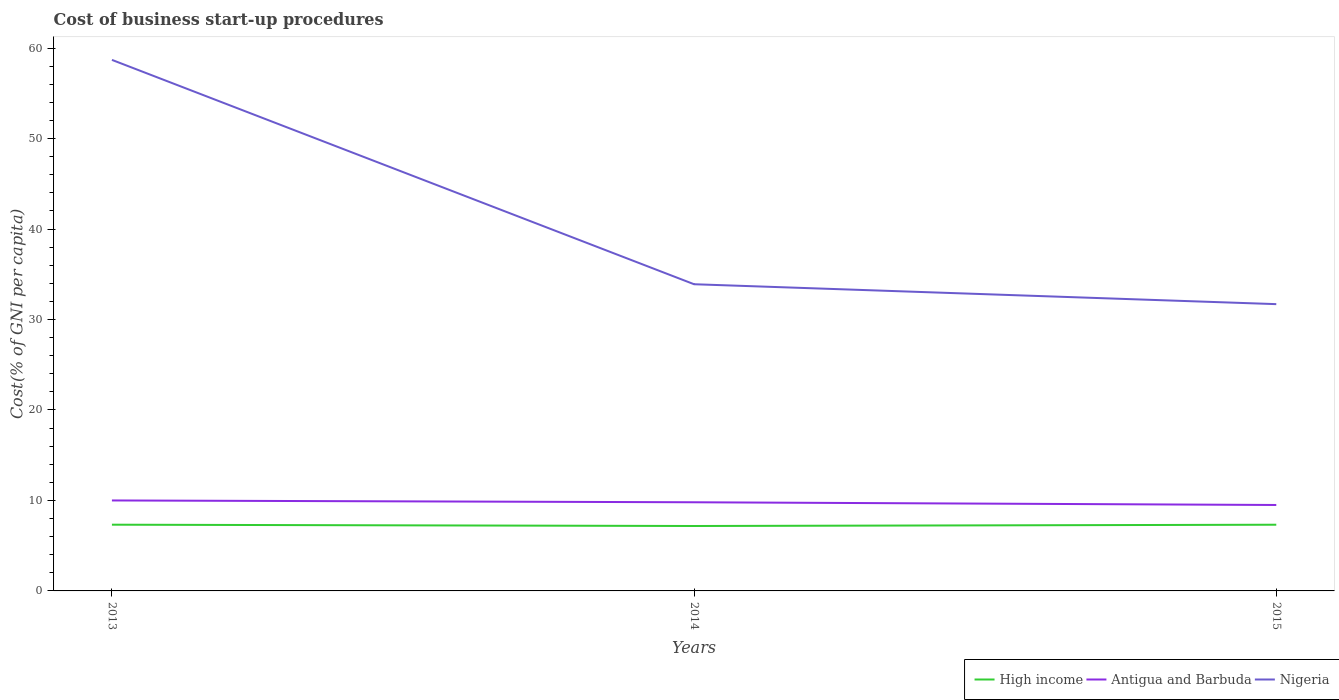Across all years, what is the maximum cost of business start-up procedures in High income?
Make the answer very short. 7.18. In which year was the cost of business start-up procedures in Nigeria maximum?
Ensure brevity in your answer.  2015. What is the total cost of business start-up procedures in High income in the graph?
Provide a short and direct response. -0.14. What is the difference between the highest and the second highest cost of business start-up procedures in High income?
Your response must be concise. 0.14. What is the difference between the highest and the lowest cost of business start-up procedures in High income?
Your answer should be very brief. 2. Is the cost of business start-up procedures in Antigua and Barbuda strictly greater than the cost of business start-up procedures in High income over the years?
Ensure brevity in your answer.  No. How many lines are there?
Your answer should be very brief. 3. How many years are there in the graph?
Your response must be concise. 3. Does the graph contain any zero values?
Provide a succinct answer. No. How are the legend labels stacked?
Your response must be concise. Horizontal. What is the title of the graph?
Your answer should be compact. Cost of business start-up procedures. Does "Bolivia" appear as one of the legend labels in the graph?
Your answer should be very brief. No. What is the label or title of the Y-axis?
Your answer should be very brief. Cost(% of GNI per capita). What is the Cost(% of GNI per capita) in High income in 2013?
Provide a succinct answer. 7.32. What is the Cost(% of GNI per capita) of Antigua and Barbuda in 2013?
Your response must be concise. 10. What is the Cost(% of GNI per capita) of Nigeria in 2013?
Your answer should be compact. 58.7. What is the Cost(% of GNI per capita) of High income in 2014?
Provide a short and direct response. 7.18. What is the Cost(% of GNI per capita) in Antigua and Barbuda in 2014?
Your answer should be compact. 9.8. What is the Cost(% of GNI per capita) of Nigeria in 2014?
Ensure brevity in your answer.  33.9. What is the Cost(% of GNI per capita) in High income in 2015?
Offer a very short reply. 7.32. What is the Cost(% of GNI per capita) of Nigeria in 2015?
Offer a terse response. 31.7. Across all years, what is the maximum Cost(% of GNI per capita) of High income?
Your answer should be very brief. 7.32. Across all years, what is the maximum Cost(% of GNI per capita) in Antigua and Barbuda?
Ensure brevity in your answer.  10. Across all years, what is the maximum Cost(% of GNI per capita) of Nigeria?
Give a very brief answer. 58.7. Across all years, what is the minimum Cost(% of GNI per capita) in High income?
Make the answer very short. 7.18. Across all years, what is the minimum Cost(% of GNI per capita) in Antigua and Barbuda?
Give a very brief answer. 9.5. Across all years, what is the minimum Cost(% of GNI per capita) of Nigeria?
Offer a terse response. 31.7. What is the total Cost(% of GNI per capita) of High income in the graph?
Provide a succinct answer. 21.82. What is the total Cost(% of GNI per capita) in Antigua and Barbuda in the graph?
Make the answer very short. 29.3. What is the total Cost(% of GNI per capita) in Nigeria in the graph?
Your answer should be very brief. 124.3. What is the difference between the Cost(% of GNI per capita) in High income in 2013 and that in 2014?
Keep it short and to the point. 0.14. What is the difference between the Cost(% of GNI per capita) of Nigeria in 2013 and that in 2014?
Provide a succinct answer. 24.8. What is the difference between the Cost(% of GNI per capita) of High income in 2013 and that in 2015?
Keep it short and to the point. 0. What is the difference between the Cost(% of GNI per capita) of Antigua and Barbuda in 2013 and that in 2015?
Keep it short and to the point. 0.5. What is the difference between the Cost(% of GNI per capita) of Nigeria in 2013 and that in 2015?
Give a very brief answer. 27. What is the difference between the Cost(% of GNI per capita) in High income in 2014 and that in 2015?
Provide a short and direct response. -0.14. What is the difference between the Cost(% of GNI per capita) of Antigua and Barbuda in 2014 and that in 2015?
Provide a succinct answer. 0.3. What is the difference between the Cost(% of GNI per capita) of Nigeria in 2014 and that in 2015?
Provide a short and direct response. 2.2. What is the difference between the Cost(% of GNI per capita) of High income in 2013 and the Cost(% of GNI per capita) of Antigua and Barbuda in 2014?
Offer a very short reply. -2.48. What is the difference between the Cost(% of GNI per capita) of High income in 2013 and the Cost(% of GNI per capita) of Nigeria in 2014?
Keep it short and to the point. -26.58. What is the difference between the Cost(% of GNI per capita) in Antigua and Barbuda in 2013 and the Cost(% of GNI per capita) in Nigeria in 2014?
Offer a very short reply. -23.9. What is the difference between the Cost(% of GNI per capita) of High income in 2013 and the Cost(% of GNI per capita) of Antigua and Barbuda in 2015?
Provide a succinct answer. -2.18. What is the difference between the Cost(% of GNI per capita) in High income in 2013 and the Cost(% of GNI per capita) in Nigeria in 2015?
Provide a succinct answer. -24.38. What is the difference between the Cost(% of GNI per capita) in Antigua and Barbuda in 2013 and the Cost(% of GNI per capita) in Nigeria in 2015?
Offer a terse response. -21.7. What is the difference between the Cost(% of GNI per capita) of High income in 2014 and the Cost(% of GNI per capita) of Antigua and Barbuda in 2015?
Keep it short and to the point. -2.32. What is the difference between the Cost(% of GNI per capita) of High income in 2014 and the Cost(% of GNI per capita) of Nigeria in 2015?
Keep it short and to the point. -24.52. What is the difference between the Cost(% of GNI per capita) of Antigua and Barbuda in 2014 and the Cost(% of GNI per capita) of Nigeria in 2015?
Offer a terse response. -21.9. What is the average Cost(% of GNI per capita) in High income per year?
Your answer should be very brief. 7.27. What is the average Cost(% of GNI per capita) in Antigua and Barbuda per year?
Make the answer very short. 9.77. What is the average Cost(% of GNI per capita) in Nigeria per year?
Your answer should be very brief. 41.43. In the year 2013, what is the difference between the Cost(% of GNI per capita) in High income and Cost(% of GNI per capita) in Antigua and Barbuda?
Give a very brief answer. -2.68. In the year 2013, what is the difference between the Cost(% of GNI per capita) in High income and Cost(% of GNI per capita) in Nigeria?
Your answer should be compact. -51.38. In the year 2013, what is the difference between the Cost(% of GNI per capita) in Antigua and Barbuda and Cost(% of GNI per capita) in Nigeria?
Your answer should be compact. -48.7. In the year 2014, what is the difference between the Cost(% of GNI per capita) in High income and Cost(% of GNI per capita) in Antigua and Barbuda?
Offer a terse response. -2.62. In the year 2014, what is the difference between the Cost(% of GNI per capita) in High income and Cost(% of GNI per capita) in Nigeria?
Offer a terse response. -26.72. In the year 2014, what is the difference between the Cost(% of GNI per capita) in Antigua and Barbuda and Cost(% of GNI per capita) in Nigeria?
Your answer should be very brief. -24.1. In the year 2015, what is the difference between the Cost(% of GNI per capita) of High income and Cost(% of GNI per capita) of Antigua and Barbuda?
Give a very brief answer. -2.18. In the year 2015, what is the difference between the Cost(% of GNI per capita) in High income and Cost(% of GNI per capita) in Nigeria?
Give a very brief answer. -24.38. In the year 2015, what is the difference between the Cost(% of GNI per capita) of Antigua and Barbuda and Cost(% of GNI per capita) of Nigeria?
Your answer should be very brief. -22.2. What is the ratio of the Cost(% of GNI per capita) in High income in 2013 to that in 2014?
Provide a short and direct response. 1.02. What is the ratio of the Cost(% of GNI per capita) in Antigua and Barbuda in 2013 to that in 2014?
Offer a very short reply. 1.02. What is the ratio of the Cost(% of GNI per capita) of Nigeria in 2013 to that in 2014?
Ensure brevity in your answer.  1.73. What is the ratio of the Cost(% of GNI per capita) of Antigua and Barbuda in 2013 to that in 2015?
Keep it short and to the point. 1.05. What is the ratio of the Cost(% of GNI per capita) of Nigeria in 2013 to that in 2015?
Make the answer very short. 1.85. What is the ratio of the Cost(% of GNI per capita) in High income in 2014 to that in 2015?
Your answer should be very brief. 0.98. What is the ratio of the Cost(% of GNI per capita) in Antigua and Barbuda in 2014 to that in 2015?
Offer a terse response. 1.03. What is the ratio of the Cost(% of GNI per capita) in Nigeria in 2014 to that in 2015?
Your response must be concise. 1.07. What is the difference between the highest and the second highest Cost(% of GNI per capita) of High income?
Make the answer very short. 0. What is the difference between the highest and the second highest Cost(% of GNI per capita) of Antigua and Barbuda?
Your answer should be very brief. 0.2. What is the difference between the highest and the second highest Cost(% of GNI per capita) of Nigeria?
Keep it short and to the point. 24.8. What is the difference between the highest and the lowest Cost(% of GNI per capita) of High income?
Give a very brief answer. 0.14. What is the difference between the highest and the lowest Cost(% of GNI per capita) of Antigua and Barbuda?
Your answer should be very brief. 0.5. What is the difference between the highest and the lowest Cost(% of GNI per capita) of Nigeria?
Give a very brief answer. 27. 